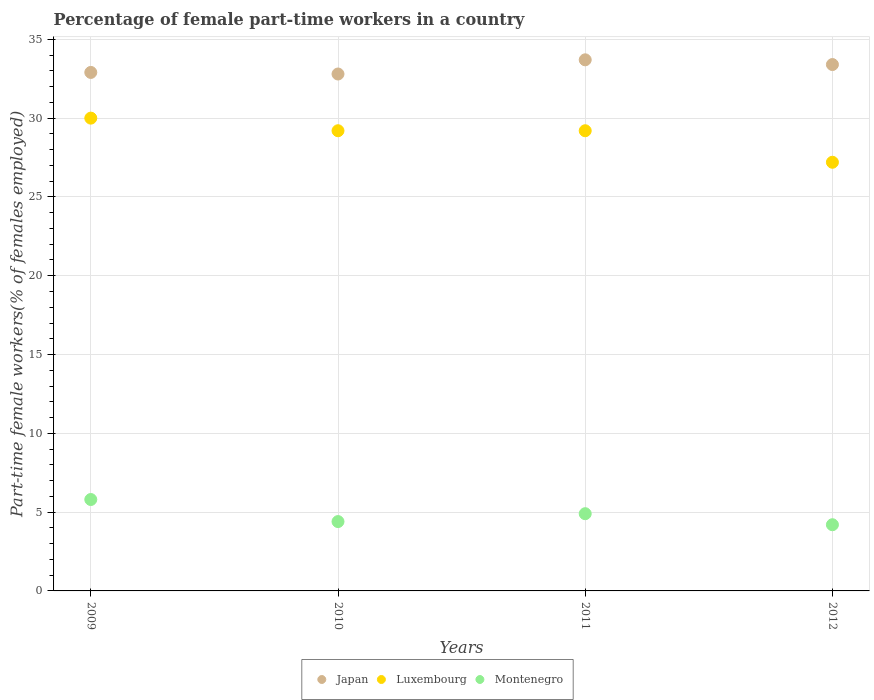What is the percentage of female part-time workers in Montenegro in 2012?
Your answer should be very brief. 4.2. Across all years, what is the maximum percentage of female part-time workers in Luxembourg?
Keep it short and to the point. 30. Across all years, what is the minimum percentage of female part-time workers in Montenegro?
Ensure brevity in your answer.  4.2. In which year was the percentage of female part-time workers in Luxembourg minimum?
Offer a very short reply. 2012. What is the total percentage of female part-time workers in Luxembourg in the graph?
Provide a succinct answer. 115.6. What is the difference between the percentage of female part-time workers in Montenegro in 2011 and the percentage of female part-time workers in Japan in 2012?
Offer a terse response. -28.5. What is the average percentage of female part-time workers in Montenegro per year?
Provide a succinct answer. 4.83. In the year 2012, what is the difference between the percentage of female part-time workers in Montenegro and percentage of female part-time workers in Japan?
Give a very brief answer. -29.2. In how many years, is the percentage of female part-time workers in Japan greater than 12 %?
Your answer should be very brief. 4. What is the ratio of the percentage of female part-time workers in Luxembourg in 2011 to that in 2012?
Your answer should be very brief. 1.07. Is the percentage of female part-time workers in Luxembourg in 2009 less than that in 2011?
Provide a short and direct response. No. Is the difference between the percentage of female part-time workers in Montenegro in 2010 and 2012 greater than the difference between the percentage of female part-time workers in Japan in 2010 and 2012?
Offer a terse response. Yes. What is the difference between the highest and the second highest percentage of female part-time workers in Montenegro?
Offer a terse response. 0.9. What is the difference between the highest and the lowest percentage of female part-time workers in Montenegro?
Make the answer very short. 1.6. Is the percentage of female part-time workers in Japan strictly greater than the percentage of female part-time workers in Luxembourg over the years?
Keep it short and to the point. Yes. Is the percentage of female part-time workers in Luxembourg strictly less than the percentage of female part-time workers in Montenegro over the years?
Provide a short and direct response. No. What is the difference between two consecutive major ticks on the Y-axis?
Your answer should be very brief. 5. Does the graph contain any zero values?
Offer a terse response. No. Does the graph contain grids?
Your answer should be compact. Yes. How are the legend labels stacked?
Your answer should be compact. Horizontal. What is the title of the graph?
Provide a succinct answer. Percentage of female part-time workers in a country. Does "El Salvador" appear as one of the legend labels in the graph?
Keep it short and to the point. No. What is the label or title of the Y-axis?
Give a very brief answer. Part-time female workers(% of females employed). What is the Part-time female workers(% of females employed) of Japan in 2009?
Make the answer very short. 32.9. What is the Part-time female workers(% of females employed) of Montenegro in 2009?
Ensure brevity in your answer.  5.8. What is the Part-time female workers(% of females employed) in Japan in 2010?
Give a very brief answer. 32.8. What is the Part-time female workers(% of females employed) in Luxembourg in 2010?
Offer a very short reply. 29.2. What is the Part-time female workers(% of females employed) of Montenegro in 2010?
Offer a very short reply. 4.4. What is the Part-time female workers(% of females employed) in Japan in 2011?
Your answer should be very brief. 33.7. What is the Part-time female workers(% of females employed) of Luxembourg in 2011?
Provide a short and direct response. 29.2. What is the Part-time female workers(% of females employed) in Montenegro in 2011?
Give a very brief answer. 4.9. What is the Part-time female workers(% of females employed) of Japan in 2012?
Offer a very short reply. 33.4. What is the Part-time female workers(% of females employed) of Luxembourg in 2012?
Provide a short and direct response. 27.2. What is the Part-time female workers(% of females employed) of Montenegro in 2012?
Make the answer very short. 4.2. Across all years, what is the maximum Part-time female workers(% of females employed) in Japan?
Your response must be concise. 33.7. Across all years, what is the maximum Part-time female workers(% of females employed) of Montenegro?
Your response must be concise. 5.8. Across all years, what is the minimum Part-time female workers(% of females employed) of Japan?
Make the answer very short. 32.8. Across all years, what is the minimum Part-time female workers(% of females employed) of Luxembourg?
Keep it short and to the point. 27.2. Across all years, what is the minimum Part-time female workers(% of females employed) in Montenegro?
Keep it short and to the point. 4.2. What is the total Part-time female workers(% of females employed) of Japan in the graph?
Your response must be concise. 132.8. What is the total Part-time female workers(% of females employed) in Luxembourg in the graph?
Your answer should be very brief. 115.6. What is the total Part-time female workers(% of females employed) of Montenegro in the graph?
Offer a terse response. 19.3. What is the difference between the Part-time female workers(% of females employed) of Montenegro in 2009 and that in 2010?
Your answer should be compact. 1.4. What is the difference between the Part-time female workers(% of females employed) of Montenegro in 2009 and that in 2011?
Provide a short and direct response. 0.9. What is the difference between the Part-time female workers(% of females employed) of Luxembourg in 2009 and that in 2012?
Offer a terse response. 2.8. What is the difference between the Part-time female workers(% of females employed) of Montenegro in 2009 and that in 2012?
Keep it short and to the point. 1.6. What is the difference between the Part-time female workers(% of females employed) of Luxembourg in 2010 and that in 2011?
Make the answer very short. 0. What is the difference between the Part-time female workers(% of females employed) of Montenegro in 2010 and that in 2011?
Keep it short and to the point. -0.5. What is the difference between the Part-time female workers(% of females employed) of Japan in 2010 and that in 2012?
Offer a very short reply. -0.6. What is the difference between the Part-time female workers(% of females employed) in Luxembourg in 2011 and that in 2012?
Give a very brief answer. 2. What is the difference between the Part-time female workers(% of females employed) of Japan in 2009 and the Part-time female workers(% of females employed) of Luxembourg in 2010?
Offer a terse response. 3.7. What is the difference between the Part-time female workers(% of females employed) in Luxembourg in 2009 and the Part-time female workers(% of females employed) in Montenegro in 2010?
Offer a very short reply. 25.6. What is the difference between the Part-time female workers(% of females employed) in Japan in 2009 and the Part-time female workers(% of females employed) in Luxembourg in 2011?
Make the answer very short. 3.7. What is the difference between the Part-time female workers(% of females employed) of Japan in 2009 and the Part-time female workers(% of females employed) of Montenegro in 2011?
Offer a terse response. 28. What is the difference between the Part-time female workers(% of females employed) of Luxembourg in 2009 and the Part-time female workers(% of females employed) of Montenegro in 2011?
Provide a succinct answer. 25.1. What is the difference between the Part-time female workers(% of females employed) in Japan in 2009 and the Part-time female workers(% of females employed) in Montenegro in 2012?
Ensure brevity in your answer.  28.7. What is the difference between the Part-time female workers(% of females employed) of Luxembourg in 2009 and the Part-time female workers(% of females employed) of Montenegro in 2012?
Give a very brief answer. 25.8. What is the difference between the Part-time female workers(% of females employed) in Japan in 2010 and the Part-time female workers(% of females employed) in Montenegro in 2011?
Ensure brevity in your answer.  27.9. What is the difference between the Part-time female workers(% of females employed) of Luxembourg in 2010 and the Part-time female workers(% of females employed) of Montenegro in 2011?
Make the answer very short. 24.3. What is the difference between the Part-time female workers(% of females employed) of Japan in 2010 and the Part-time female workers(% of females employed) of Montenegro in 2012?
Provide a short and direct response. 28.6. What is the difference between the Part-time female workers(% of females employed) in Japan in 2011 and the Part-time female workers(% of females employed) in Montenegro in 2012?
Your answer should be compact. 29.5. What is the difference between the Part-time female workers(% of females employed) of Luxembourg in 2011 and the Part-time female workers(% of females employed) of Montenegro in 2012?
Your answer should be compact. 25. What is the average Part-time female workers(% of females employed) in Japan per year?
Ensure brevity in your answer.  33.2. What is the average Part-time female workers(% of females employed) of Luxembourg per year?
Offer a very short reply. 28.9. What is the average Part-time female workers(% of females employed) in Montenegro per year?
Provide a succinct answer. 4.83. In the year 2009, what is the difference between the Part-time female workers(% of females employed) in Japan and Part-time female workers(% of females employed) in Luxembourg?
Offer a very short reply. 2.9. In the year 2009, what is the difference between the Part-time female workers(% of females employed) of Japan and Part-time female workers(% of females employed) of Montenegro?
Provide a succinct answer. 27.1. In the year 2009, what is the difference between the Part-time female workers(% of females employed) of Luxembourg and Part-time female workers(% of females employed) of Montenegro?
Your response must be concise. 24.2. In the year 2010, what is the difference between the Part-time female workers(% of females employed) in Japan and Part-time female workers(% of females employed) in Montenegro?
Your answer should be very brief. 28.4. In the year 2010, what is the difference between the Part-time female workers(% of females employed) in Luxembourg and Part-time female workers(% of females employed) in Montenegro?
Ensure brevity in your answer.  24.8. In the year 2011, what is the difference between the Part-time female workers(% of females employed) in Japan and Part-time female workers(% of females employed) in Montenegro?
Your response must be concise. 28.8. In the year 2011, what is the difference between the Part-time female workers(% of females employed) of Luxembourg and Part-time female workers(% of females employed) of Montenegro?
Give a very brief answer. 24.3. In the year 2012, what is the difference between the Part-time female workers(% of females employed) in Japan and Part-time female workers(% of females employed) in Montenegro?
Offer a very short reply. 29.2. In the year 2012, what is the difference between the Part-time female workers(% of females employed) in Luxembourg and Part-time female workers(% of females employed) in Montenegro?
Offer a terse response. 23. What is the ratio of the Part-time female workers(% of females employed) in Japan in 2009 to that in 2010?
Your response must be concise. 1. What is the ratio of the Part-time female workers(% of females employed) of Luxembourg in 2009 to that in 2010?
Your answer should be compact. 1.03. What is the ratio of the Part-time female workers(% of females employed) in Montenegro in 2009 to that in 2010?
Make the answer very short. 1.32. What is the ratio of the Part-time female workers(% of females employed) of Japan in 2009 to that in 2011?
Offer a very short reply. 0.98. What is the ratio of the Part-time female workers(% of females employed) in Luxembourg in 2009 to that in 2011?
Keep it short and to the point. 1.03. What is the ratio of the Part-time female workers(% of females employed) in Montenegro in 2009 to that in 2011?
Offer a very short reply. 1.18. What is the ratio of the Part-time female workers(% of females employed) in Japan in 2009 to that in 2012?
Offer a very short reply. 0.98. What is the ratio of the Part-time female workers(% of females employed) in Luxembourg in 2009 to that in 2012?
Your answer should be very brief. 1.1. What is the ratio of the Part-time female workers(% of females employed) in Montenegro in 2009 to that in 2012?
Your response must be concise. 1.38. What is the ratio of the Part-time female workers(% of females employed) in Japan in 2010 to that in 2011?
Your answer should be compact. 0.97. What is the ratio of the Part-time female workers(% of females employed) of Luxembourg in 2010 to that in 2011?
Keep it short and to the point. 1. What is the ratio of the Part-time female workers(% of females employed) in Montenegro in 2010 to that in 2011?
Offer a terse response. 0.9. What is the ratio of the Part-time female workers(% of females employed) of Japan in 2010 to that in 2012?
Your answer should be very brief. 0.98. What is the ratio of the Part-time female workers(% of females employed) in Luxembourg in 2010 to that in 2012?
Your answer should be very brief. 1.07. What is the ratio of the Part-time female workers(% of females employed) of Montenegro in 2010 to that in 2012?
Make the answer very short. 1.05. What is the ratio of the Part-time female workers(% of females employed) of Luxembourg in 2011 to that in 2012?
Offer a very short reply. 1.07. What is the difference between the highest and the lowest Part-time female workers(% of females employed) of Luxembourg?
Your response must be concise. 2.8. What is the difference between the highest and the lowest Part-time female workers(% of females employed) of Montenegro?
Give a very brief answer. 1.6. 